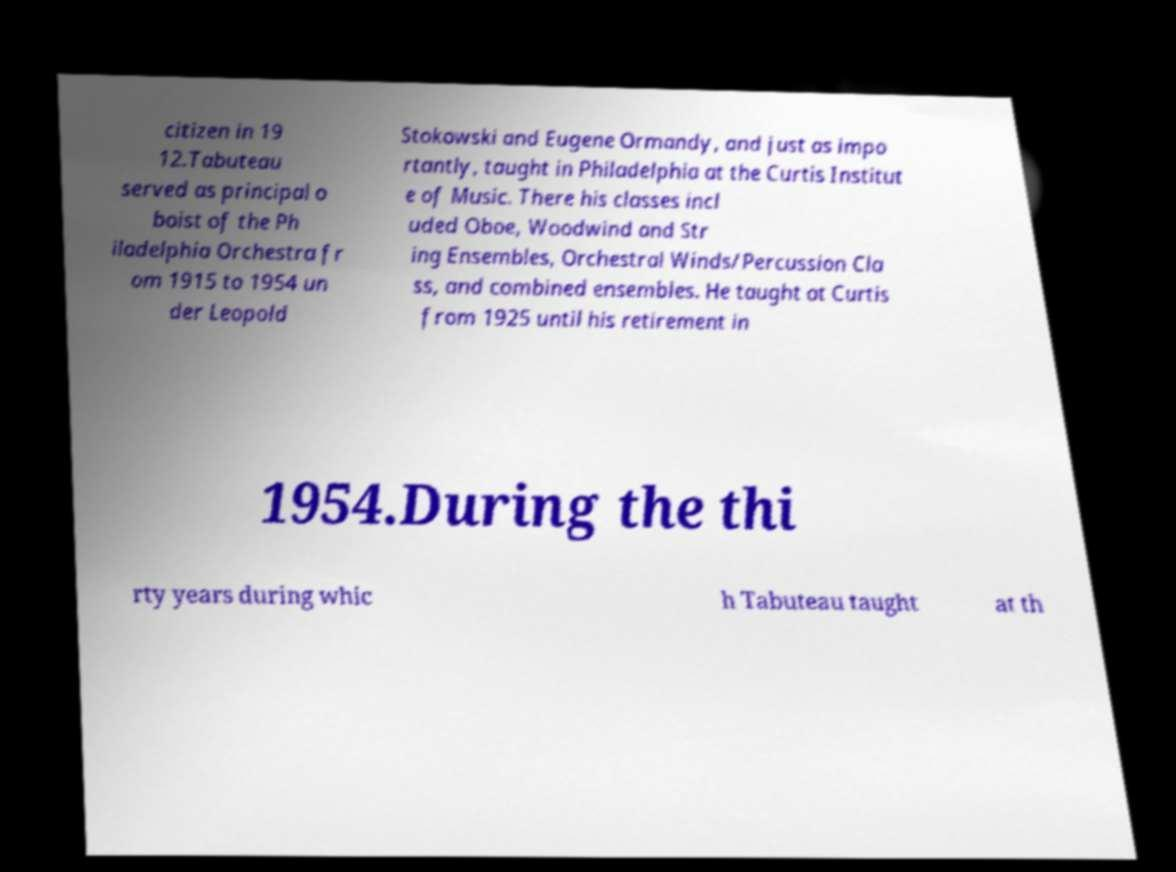Please identify and transcribe the text found in this image. citizen in 19 12.Tabuteau served as principal o boist of the Ph iladelphia Orchestra fr om 1915 to 1954 un der Leopold Stokowski and Eugene Ormandy, and just as impo rtantly, taught in Philadelphia at the Curtis Institut e of Music. There his classes incl uded Oboe, Woodwind and Str ing Ensembles, Orchestral Winds/Percussion Cla ss, and combined ensembles. He taught at Curtis from 1925 until his retirement in 1954.During the thi rty years during whic h Tabuteau taught at th 